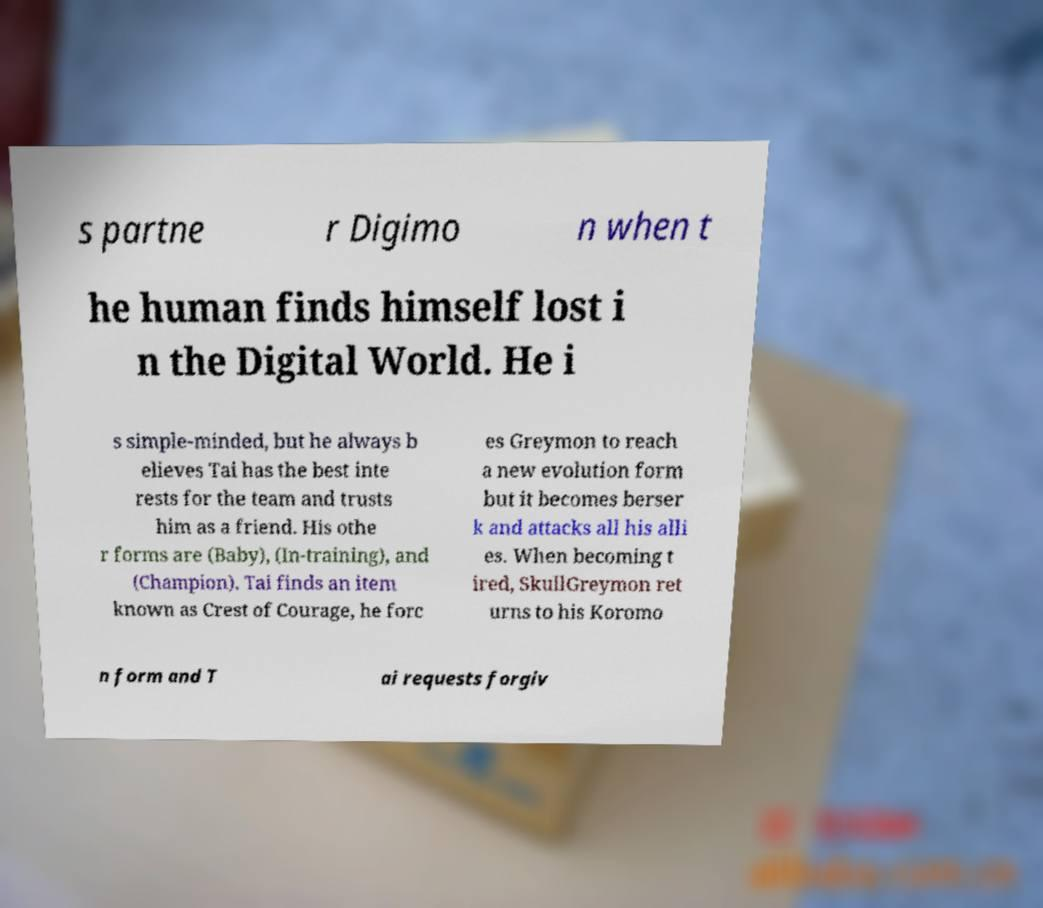I need the written content from this picture converted into text. Can you do that? s partne r Digimo n when t he human finds himself lost i n the Digital World. He i s simple-minded, but he always b elieves Tai has the best inte rests for the team and trusts him as a friend. His othe r forms are (Baby), (In-training), and (Champion). Tai finds an item known as Crest of Courage, he forc es Greymon to reach a new evolution form but it becomes berser k and attacks all his alli es. When becoming t ired, SkullGreymon ret urns to his Koromo n form and T ai requests forgiv 